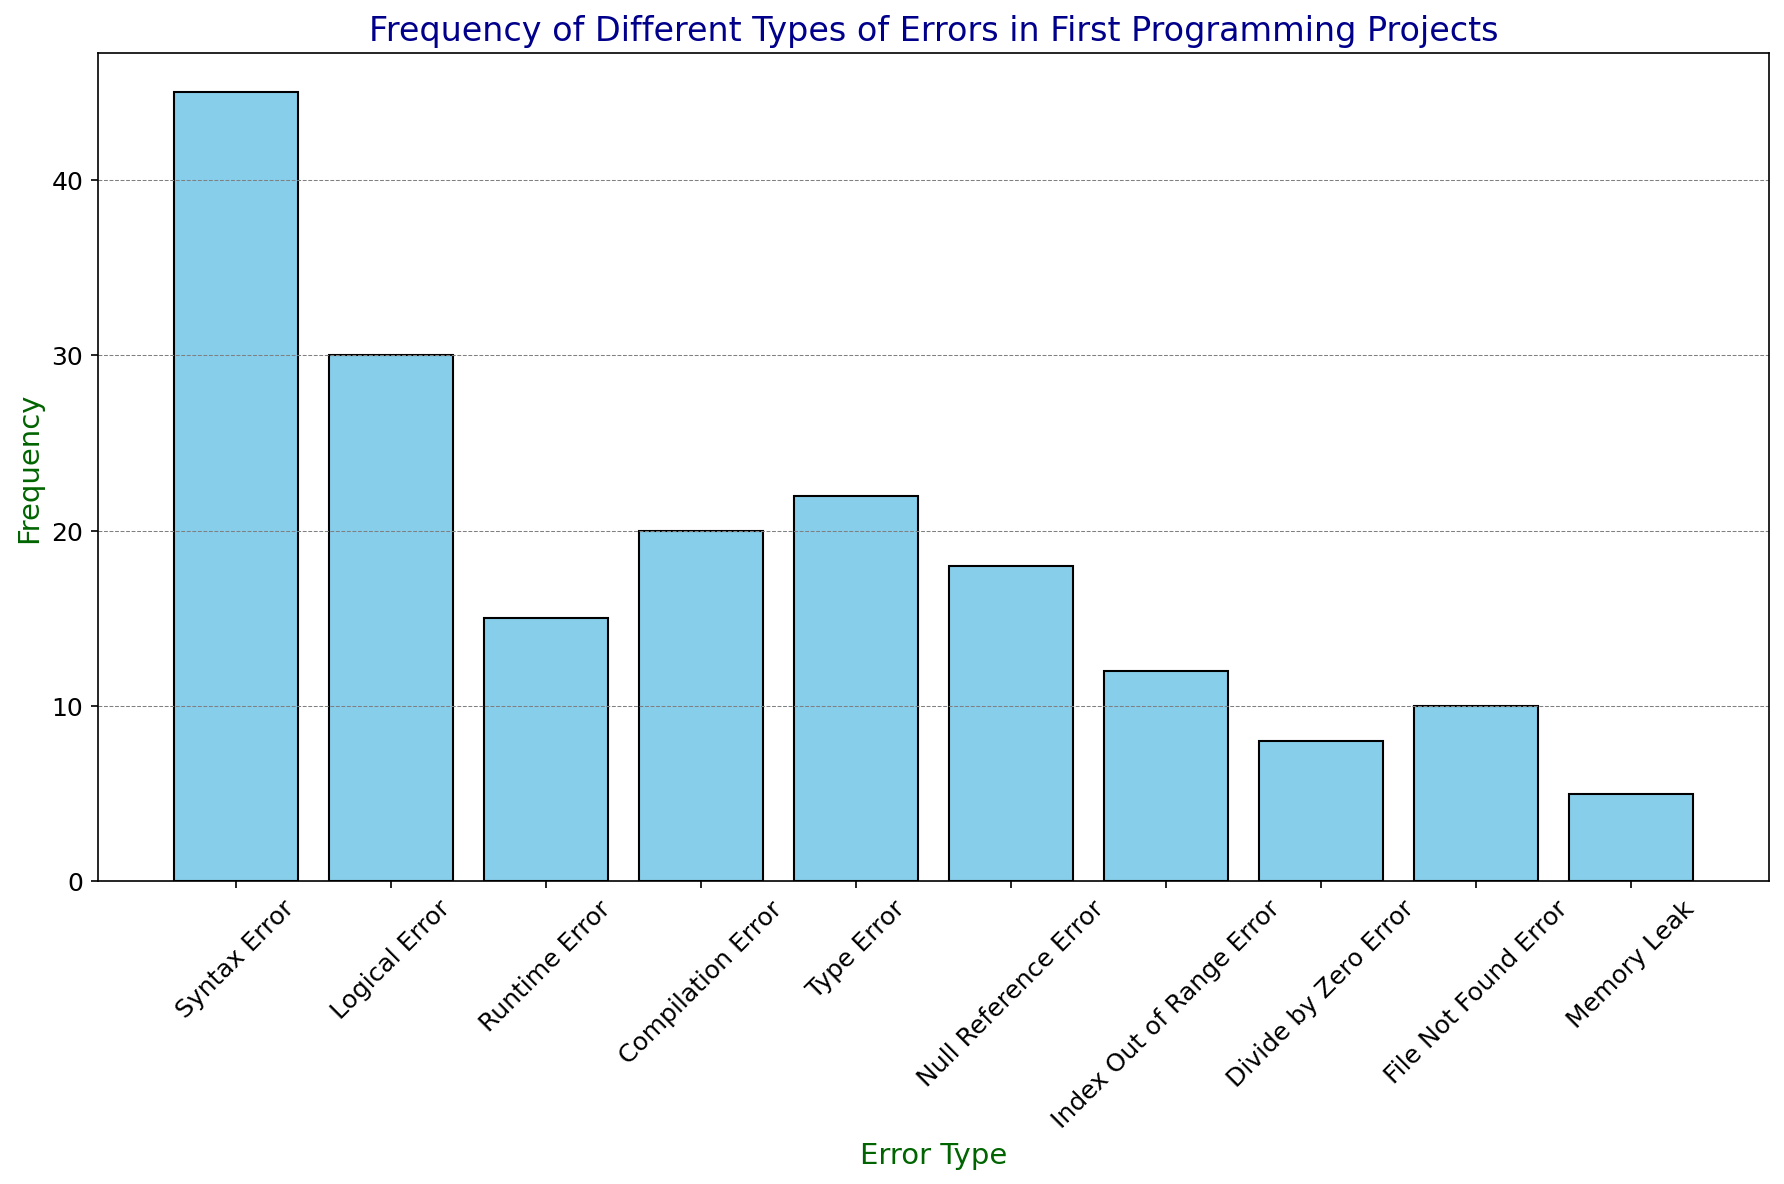What is the most common error type? Locate the tallest bar in the figure. The height represents the frequency, and the label on the x-axis under this bar is the error type. The tallest bar corresponds to "Syntax Error".
Answer: Syntax Error Which error type has a frequency of 22? Find the bar whose height corresponds to the frequency of 22 on the y-axis. The label on the x-axis under this bar represents the error type.
Answer: Type Error Is the frequency of Logical Errors greater than that of Runtime Errors? Compare the height of the bar for "Logical Error" with the height of the bar for "Runtime Error" by looking at the y-axis. The bar for "Logical Error" is taller than that for "Runtime Error".
Answer: Yes What is the total frequency of Syntax Errors and Logical Errors combined? Add the frequencies of Syntax Error and Logical Error. Syntax Error is 45 and Logical Error is 30. The total frequency is 45 + 30 = 75.
Answer: 75 Which error type has a lower frequency: Divide by Zero Error or File Not Found Error? Compare the heights of the bars for "Divide by Zero Error" and "File Not Found Error" by looking at the y-axis. The bar for "Divide by Zero Error" is shorter.
Answer: Divide by Zero Error Are there more Null Reference Errors than Compilation Errors? Compare the heights of the bars for "Null Reference Error" and "Compilation Error" by looking at the y-axis. The bar for "Compilation Error" is taller than that for "Null Reference Error".
Answer: No What is the frequency range of the errors in the figure? Identify the highest and lowest frequencies from the y-axis values of the tallest and shortest bars. The highest frequency is 45 (Syntax Error), while the lowest is 5 (Memory Leak). The frequency range is 45 - 5 = 40.
Answer: 40 What is the average frequency of Runtime Error, Type Error, and Null Reference Error? Add the frequencies of these three errors and divide by the number of error types. Runtime Error is 15, Type Error is 22, and Null Reference Error is 18. (15 + 22 + 18) / 3 = 55 / 3 ≈ 18.33.
Answer: Approximately 18.33 Are the frequencies of Compilation Errors and Index Out of Range Errors equal? Compare the heights of the bars for "Compilation Error" and "Index Out of Range Error" by looking at the y-axis. "Compilation Error" is 20, and "Index Out of Range Error" is 12.
Answer: No 